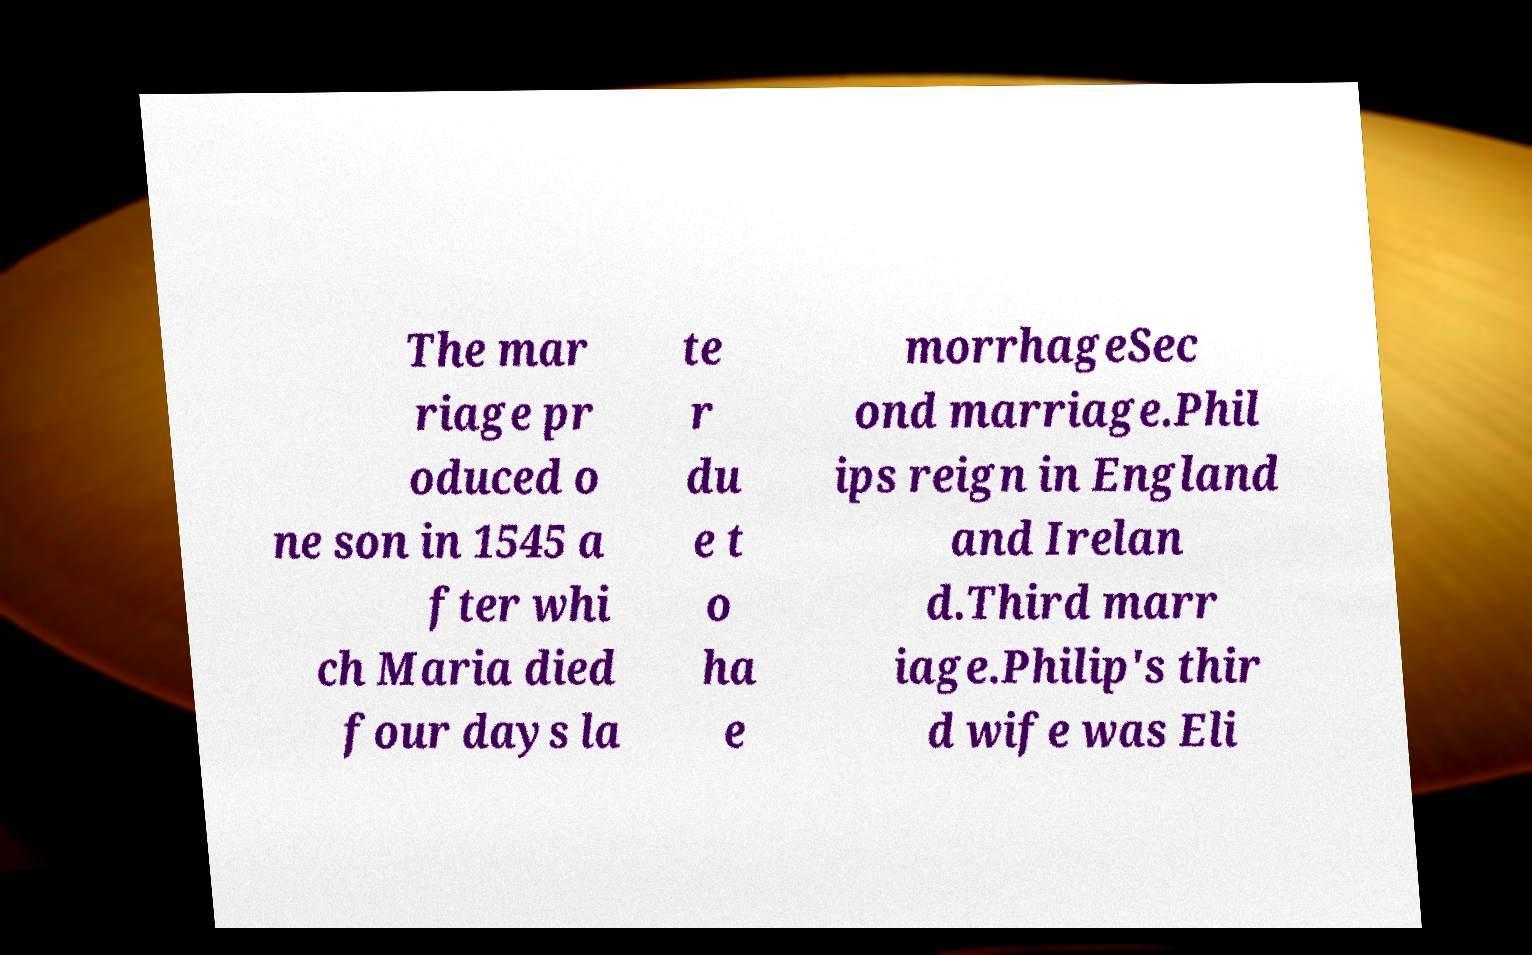For documentation purposes, I need the text within this image transcribed. Could you provide that? The mar riage pr oduced o ne son in 1545 a fter whi ch Maria died four days la te r du e t o ha e morrhageSec ond marriage.Phil ips reign in England and Irelan d.Third marr iage.Philip's thir d wife was Eli 